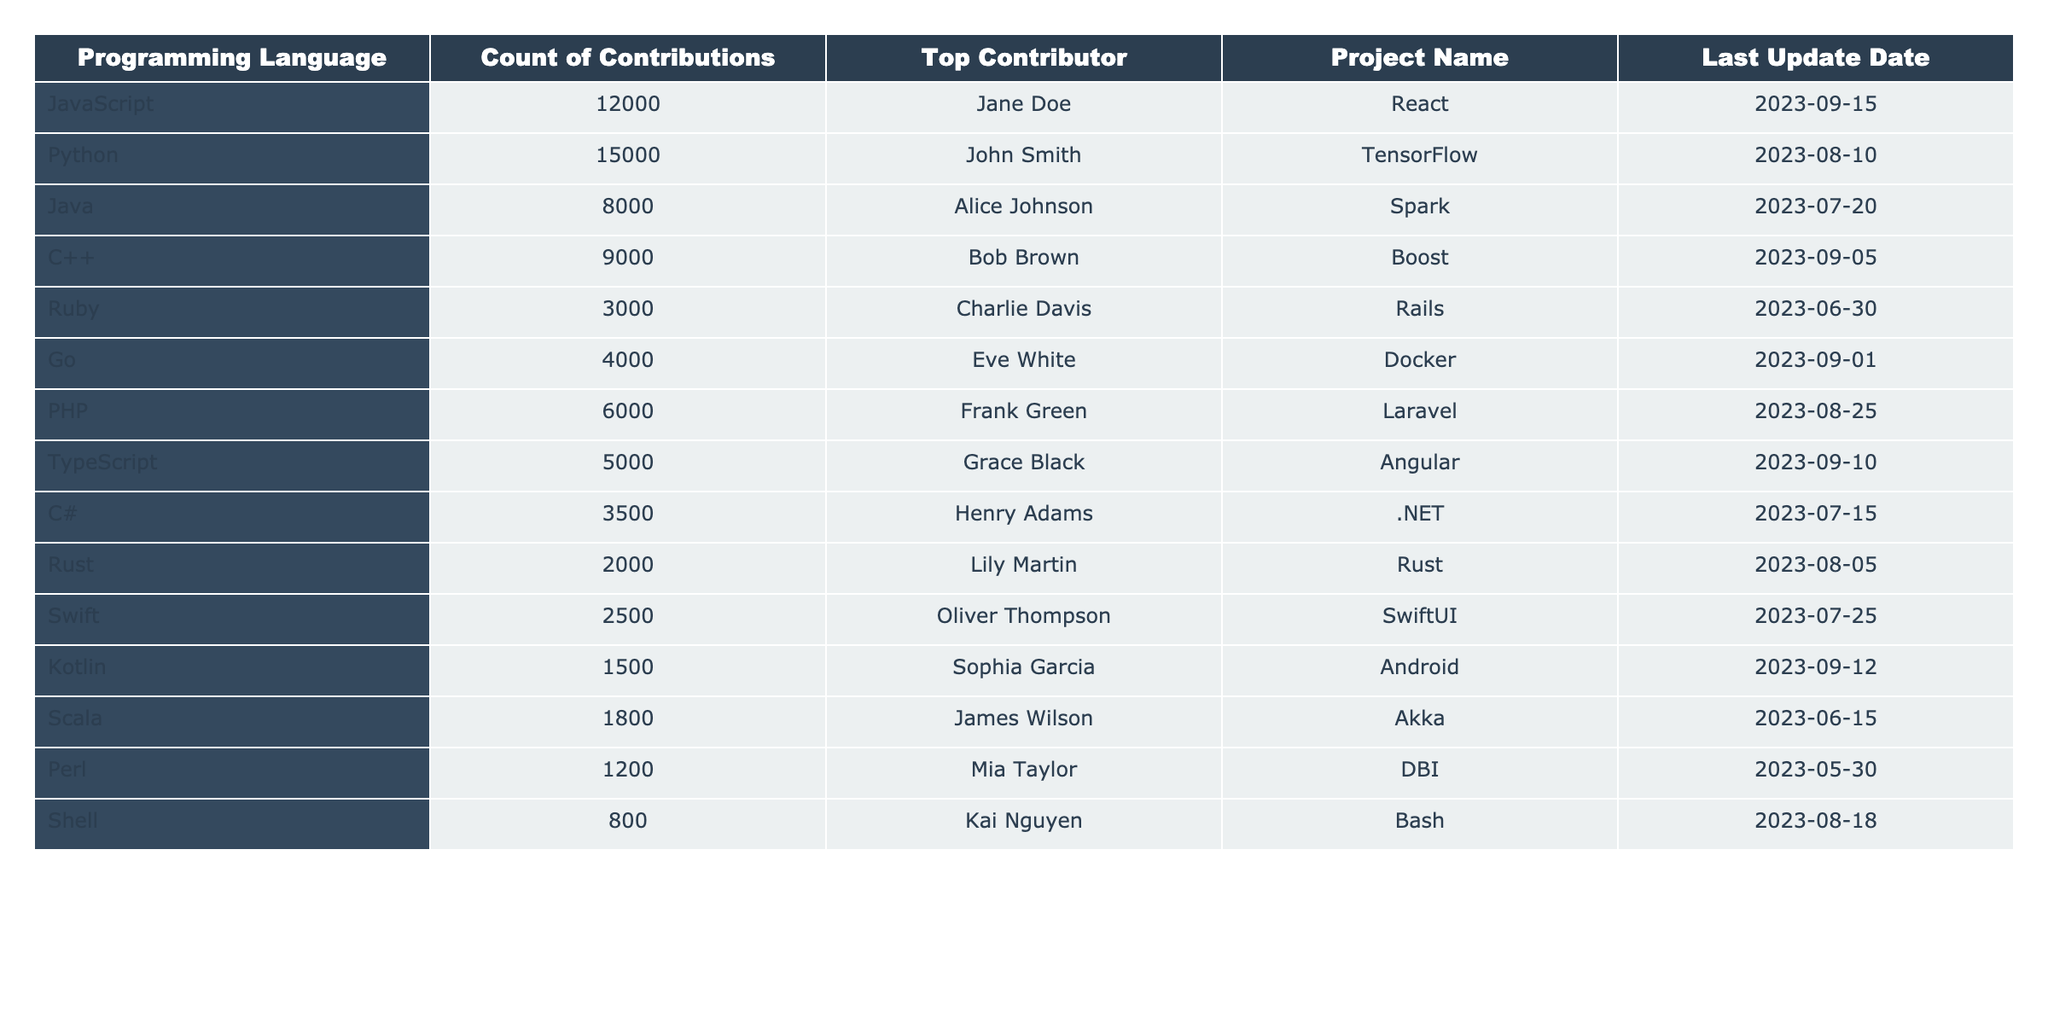What is the top programming language for contributions in 2023? By looking at the "Count of Contributions" column, the highest value is **15000**, which corresponds to **Python**.
Answer: Python Who is the top contributor for JavaScript? The table lists **Jane Doe** as the top contributor for JavaScript.
Answer: Jane Doe How many contributions did Ruby receive? The count of contributions for Ruby, as listed in the table, is **3000**.
Answer: 3000 What is the difference in contributions between Java and C++? Java has **8000** contributions and C++ has **9000** contributions, so the difference is **9000 - 8000 = 1000**.
Answer: 1000 Is there any programming language with more than 15000 contributions? The maximum contribution count is **15000** for Python, and there are no languages exceeding that value.
Answer: No Which programming language received the least contributions? Examining the "Count of Contributions," **Perl** has the lowest count at **1200**.
Answer: Perl What was the last updated project for the top contributor in Go? The top contributor for Go is **Eve White**, and the last updated project is **Docker**.
Answer: Docker If you combine the contributions of C# and Swift, what is the total? C# has **3500** contributions and Swift has **2500**. Adding these gives **3500 + 2500 = 6000**.
Answer: 6000 Which programming language had the most recent update according to the table? The last update date is **2023-09-15** for JavaScript, making it the most recent update.
Answer: JavaScript Who is the contributor for the Java project? The Java project's top contributor is **Alice Johnson**, as shown in the table.
Answer: Alice Johnson 